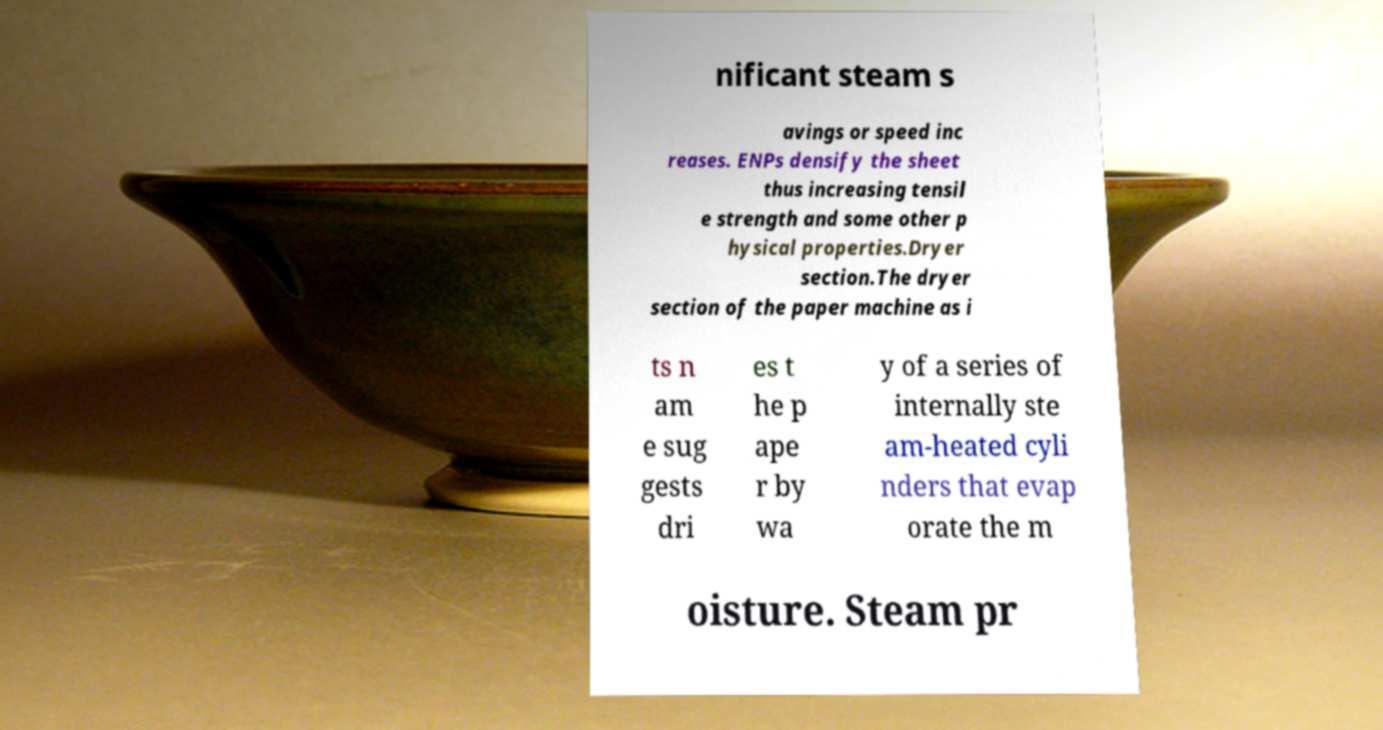There's text embedded in this image that I need extracted. Can you transcribe it verbatim? nificant steam s avings or speed inc reases. ENPs densify the sheet thus increasing tensil e strength and some other p hysical properties.Dryer section.The dryer section of the paper machine as i ts n am e sug gests dri es t he p ape r by wa y of a series of internally ste am-heated cyli nders that evap orate the m oisture. Steam pr 